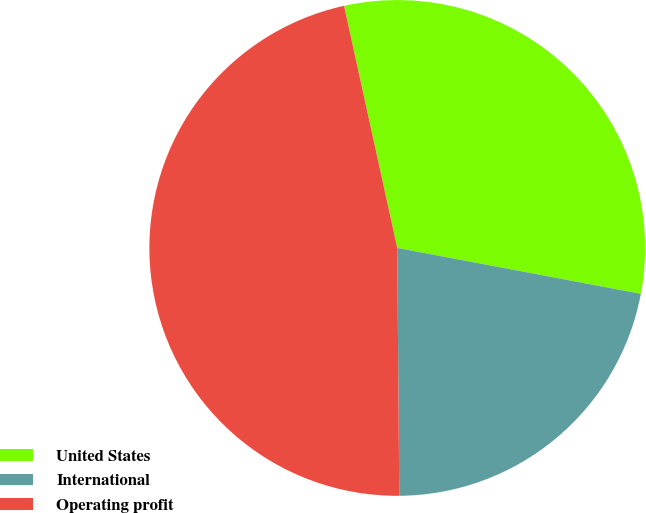Convert chart. <chart><loc_0><loc_0><loc_500><loc_500><pie_chart><fcel>United States<fcel>International<fcel>Operating profit<nl><fcel>31.41%<fcel>21.91%<fcel>46.69%<nl></chart> 